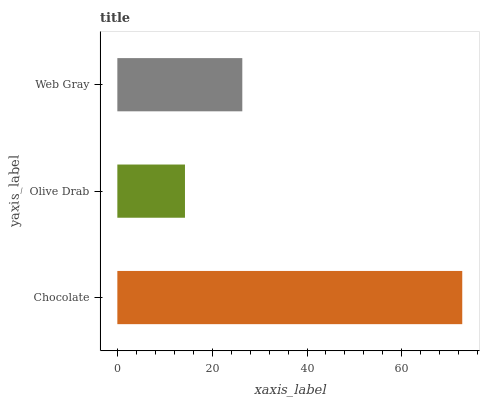Is Olive Drab the minimum?
Answer yes or no. Yes. Is Chocolate the maximum?
Answer yes or no. Yes. Is Web Gray the minimum?
Answer yes or no. No. Is Web Gray the maximum?
Answer yes or no. No. Is Web Gray greater than Olive Drab?
Answer yes or no. Yes. Is Olive Drab less than Web Gray?
Answer yes or no. Yes. Is Olive Drab greater than Web Gray?
Answer yes or no. No. Is Web Gray less than Olive Drab?
Answer yes or no. No. Is Web Gray the high median?
Answer yes or no. Yes. Is Web Gray the low median?
Answer yes or no. Yes. Is Chocolate the high median?
Answer yes or no. No. Is Olive Drab the low median?
Answer yes or no. No. 